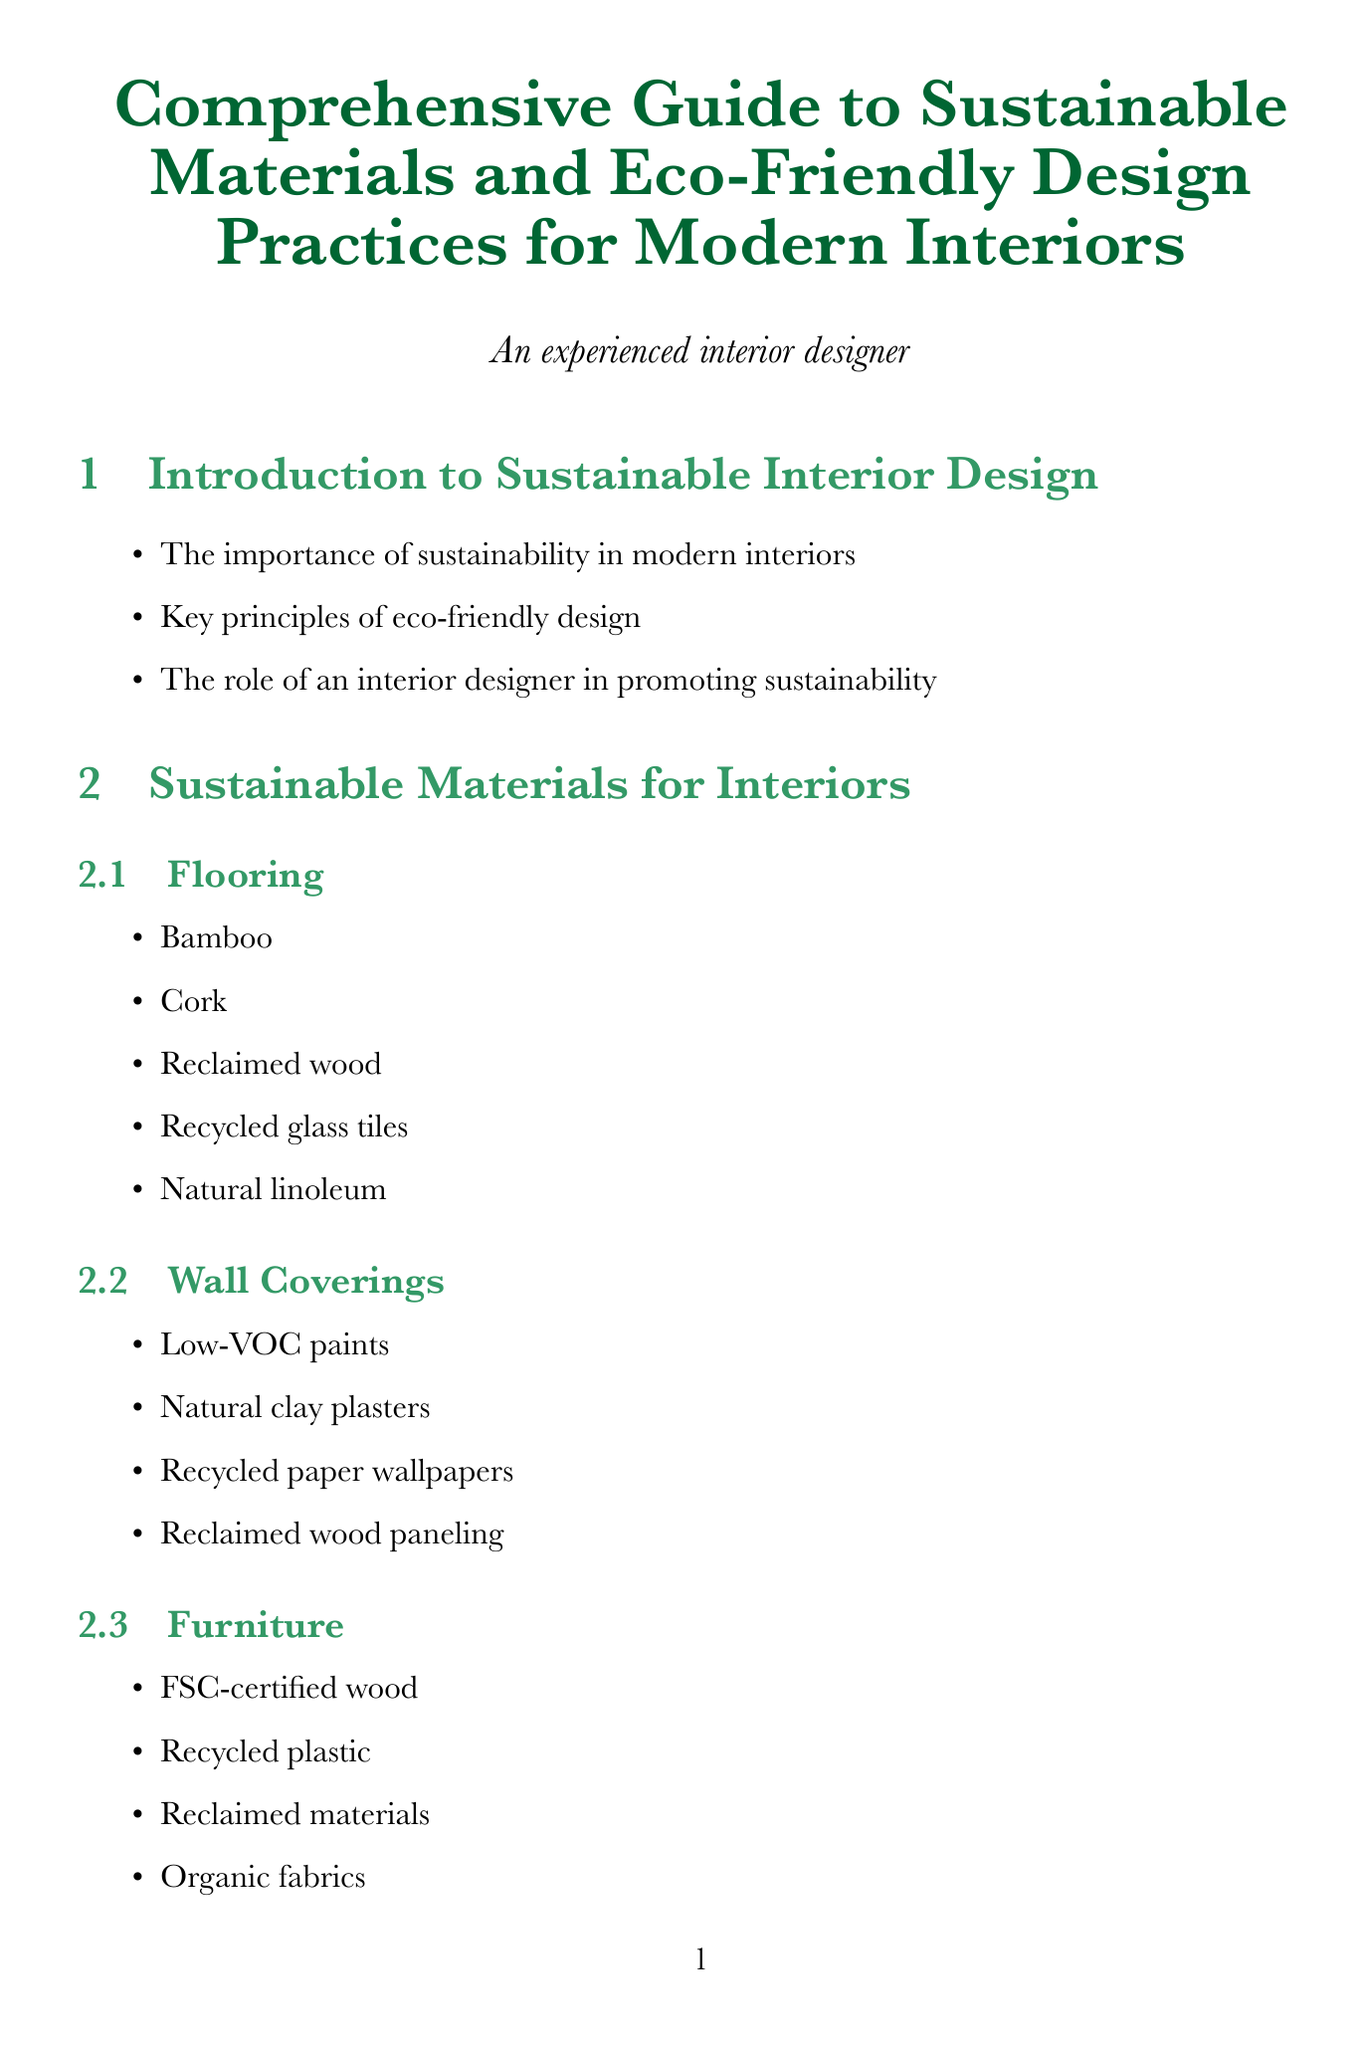What is the main focus of the guide? The guide focuses on sustainable materials and eco-friendly design practices specifically for modern interiors.
Answer: sustainable materials and eco-friendly design practices Which material is listed under Flooring? The document lists several materials under Flooring, including bamboo.
Answer: Bamboo What are the three key features of the eco-friendly urban apartment case study? The case study outlines three significant features of the project, including reclaimed wood flooring, solar-powered lighting, and a vertical garden wall.
Answer: Reclaimed wood flooring, solar-powered lighting, vertical garden wall How many certification systems are mentioned in the document? The document states three certification systems under the Certification Systems and Standards section.
Answer: 3 What strategy is mentioned for waste reduction? The document enumerates strategies including upcycling furniture and decor, which is a focus area for reducing waste.
Answer: Upcycling furniture and decor Which technology is suggested for energy management in interiors? The guide suggests the use of smart home technology for managing energy in interior design.
Answer: Smart home technology What is one principle mentioned for enhancing indoor air quality? The document discusses improving indoor air quality through the use of natural air purifying plants.
Answer: Natural air purifying plants What is the location of the sustainable office space case study? The document specifies that the sustainable office space is located in Copenhagen, Denmark.
Answer: Copenhagen, Denmark 